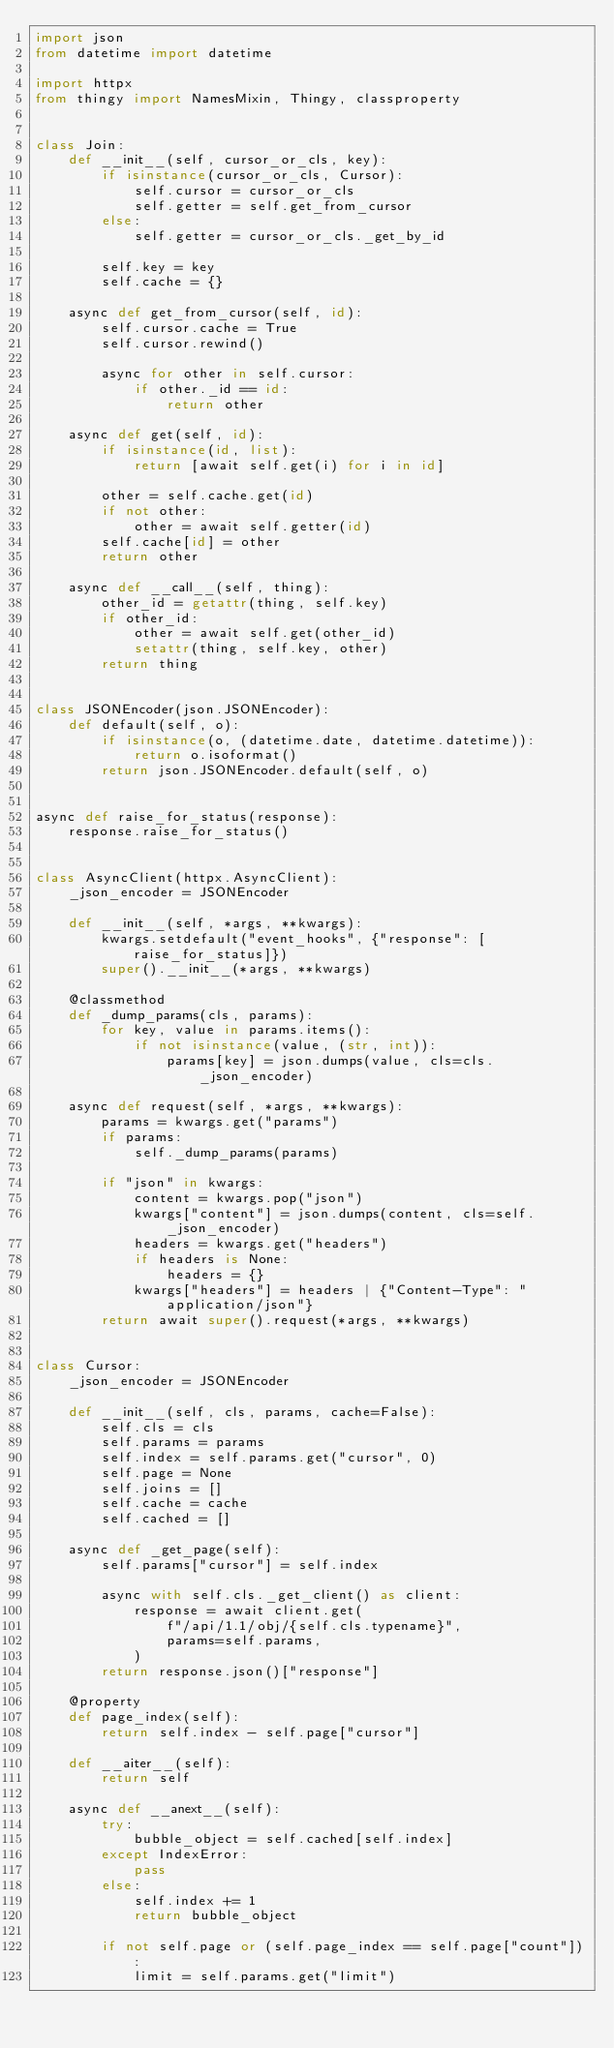Convert code to text. <code><loc_0><loc_0><loc_500><loc_500><_Python_>import json
from datetime import datetime

import httpx
from thingy import NamesMixin, Thingy, classproperty


class Join:
    def __init__(self, cursor_or_cls, key):
        if isinstance(cursor_or_cls, Cursor):
            self.cursor = cursor_or_cls
            self.getter = self.get_from_cursor
        else:
            self.getter = cursor_or_cls._get_by_id

        self.key = key
        self.cache = {}

    async def get_from_cursor(self, id):
        self.cursor.cache = True
        self.cursor.rewind()

        async for other in self.cursor:
            if other._id == id:
                return other

    async def get(self, id):
        if isinstance(id, list):
            return [await self.get(i) for i in id]

        other = self.cache.get(id)
        if not other:
            other = await self.getter(id)
        self.cache[id] = other
        return other

    async def __call__(self, thing):
        other_id = getattr(thing, self.key)
        if other_id:
            other = await self.get(other_id)
            setattr(thing, self.key, other)
        return thing


class JSONEncoder(json.JSONEncoder):
    def default(self, o):
        if isinstance(o, (datetime.date, datetime.datetime)):
            return o.isoformat()
        return json.JSONEncoder.default(self, o)


async def raise_for_status(response):
    response.raise_for_status()


class AsyncClient(httpx.AsyncClient):
    _json_encoder = JSONEncoder

    def __init__(self, *args, **kwargs):
        kwargs.setdefault("event_hooks", {"response": [raise_for_status]})
        super().__init__(*args, **kwargs)

    @classmethod
    def _dump_params(cls, params):
        for key, value in params.items():
            if not isinstance(value, (str, int)):
                params[key] = json.dumps(value, cls=cls._json_encoder)

    async def request(self, *args, **kwargs):
        params = kwargs.get("params")
        if params:
            self._dump_params(params)

        if "json" in kwargs:
            content = kwargs.pop("json")
            kwargs["content"] = json.dumps(content, cls=self._json_encoder)
            headers = kwargs.get("headers")
            if headers is None:
                headers = {}
            kwargs["headers"] = headers | {"Content-Type": "application/json"}
        return await super().request(*args, **kwargs)


class Cursor:
    _json_encoder = JSONEncoder

    def __init__(self, cls, params, cache=False):
        self.cls = cls
        self.params = params
        self.index = self.params.get("cursor", 0)
        self.page = None
        self.joins = []
        self.cache = cache
        self.cached = []

    async def _get_page(self):
        self.params["cursor"] = self.index

        async with self.cls._get_client() as client:
            response = await client.get(
                f"/api/1.1/obj/{self.cls.typename}",
                params=self.params,
            )
        return response.json()["response"]

    @property
    def page_index(self):
        return self.index - self.page["cursor"]

    def __aiter__(self):
        return self

    async def __anext__(self):
        try:
            bubble_object = self.cached[self.index]
        except IndexError:
            pass
        else:
            self.index += 1
            return bubble_object

        if not self.page or (self.page_index == self.page["count"]):
            limit = self.params.get("limit")</code> 